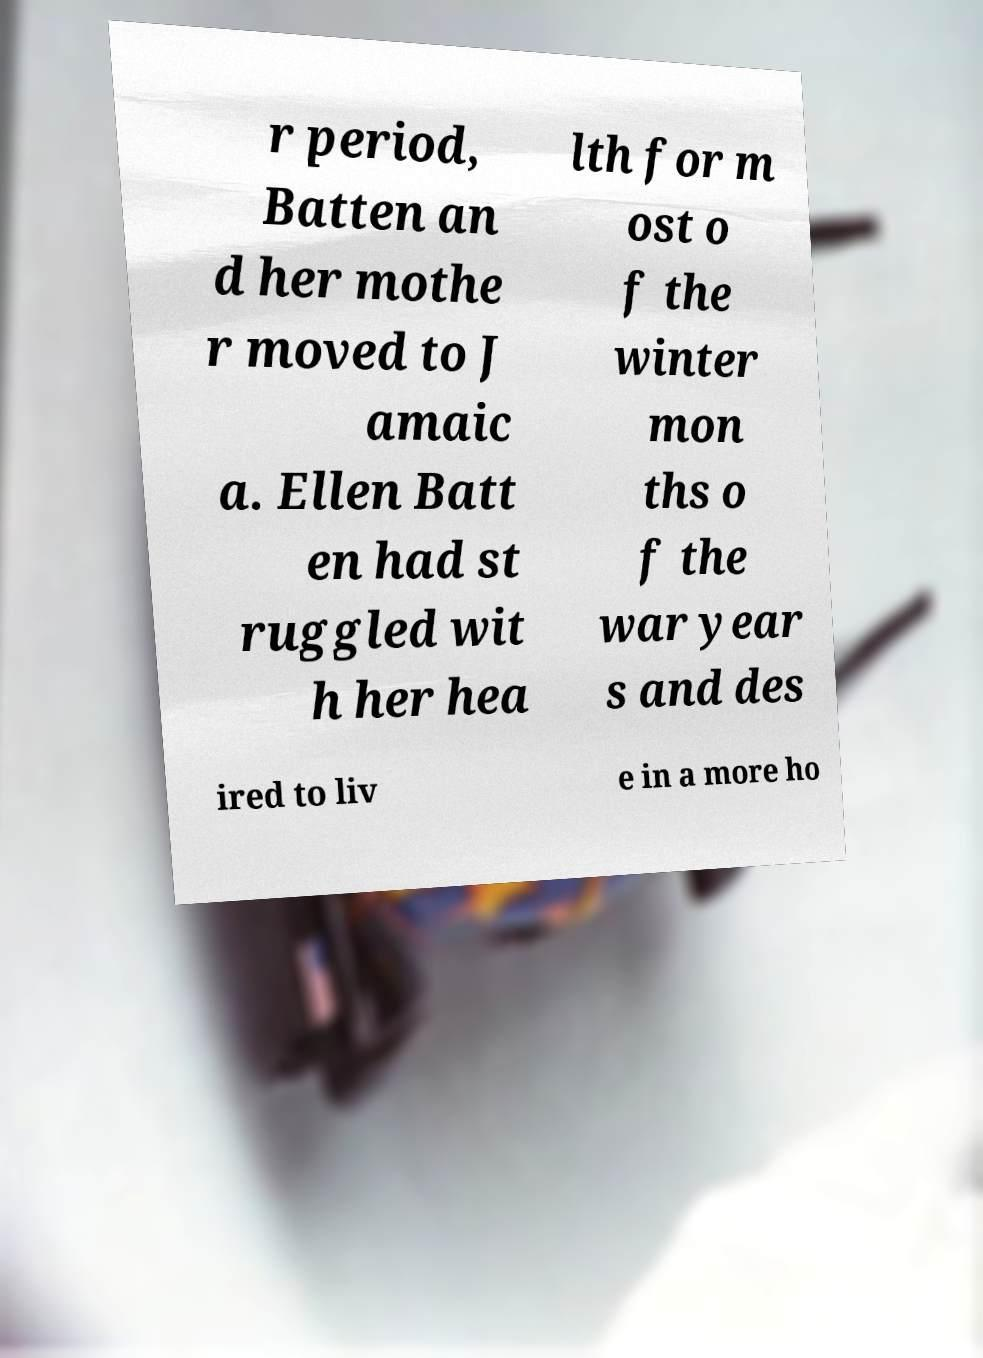Could you extract and type out the text from this image? r period, Batten an d her mothe r moved to J amaic a. Ellen Batt en had st ruggled wit h her hea lth for m ost o f the winter mon ths o f the war year s and des ired to liv e in a more ho 